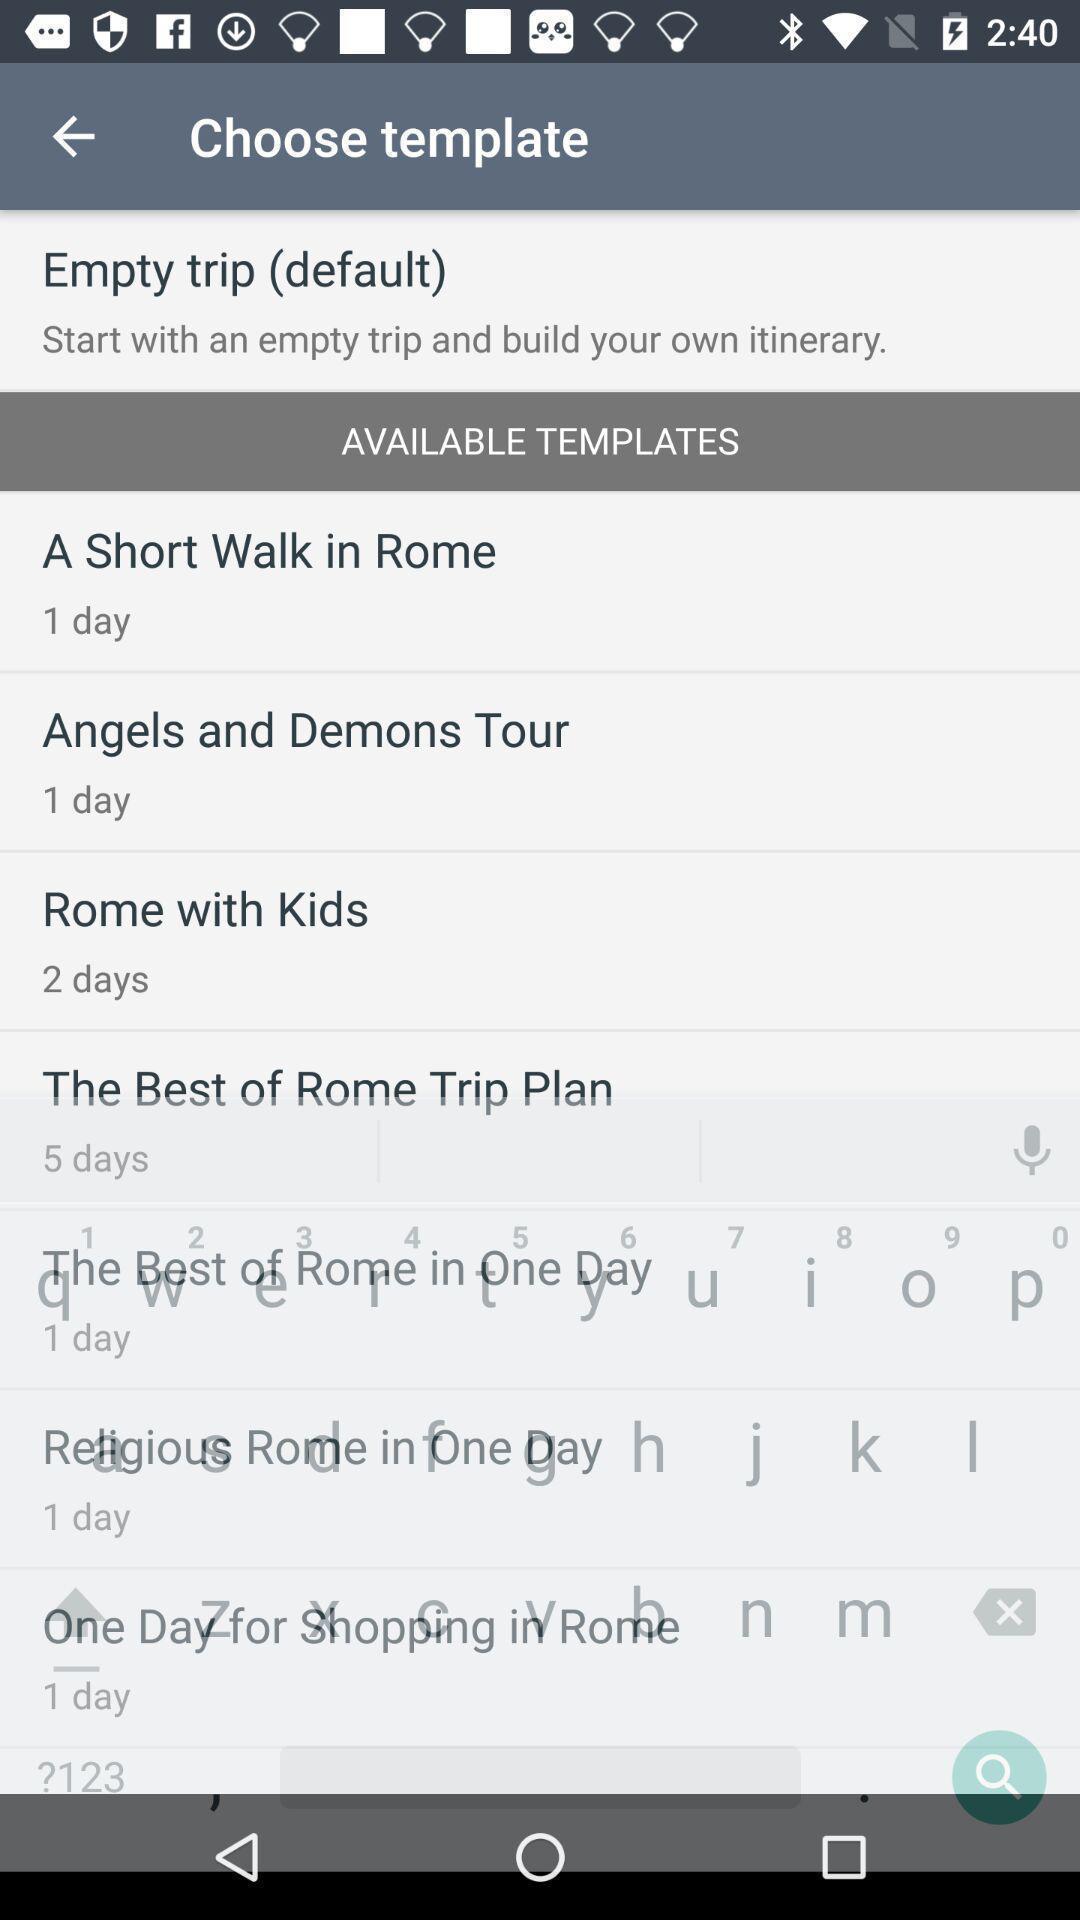What is the overall content of this screenshot? Screen shows to choose template. 